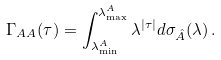<formula> <loc_0><loc_0><loc_500><loc_500>\Gamma _ { A A } ( \tau ) = \int _ { \lambda ^ { A } _ { \min } } ^ { \lambda ^ { A } _ { \max } } \lambda ^ { | \tau | } d \sigma _ { \hat { A } } ( \lambda ) \, .</formula> 